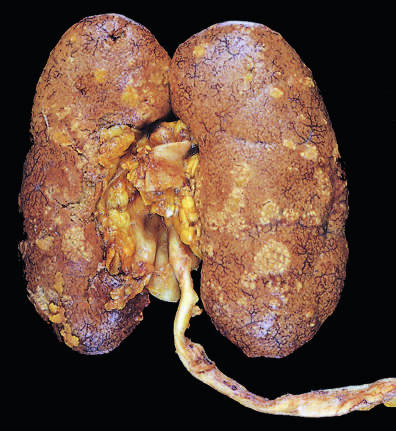what is relatively unaffected?
Answer the question using a single word or phrase. The lower pole 